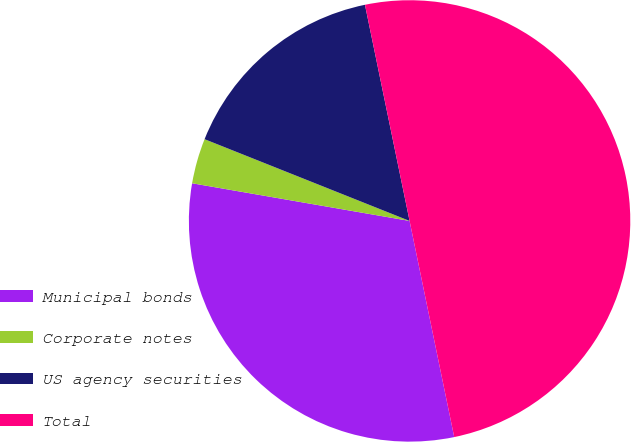Convert chart to OTSL. <chart><loc_0><loc_0><loc_500><loc_500><pie_chart><fcel>Municipal bonds<fcel>Corporate notes<fcel>US agency securities<fcel>Total<nl><fcel>30.97%<fcel>3.31%<fcel>15.72%<fcel>50.0%<nl></chart> 